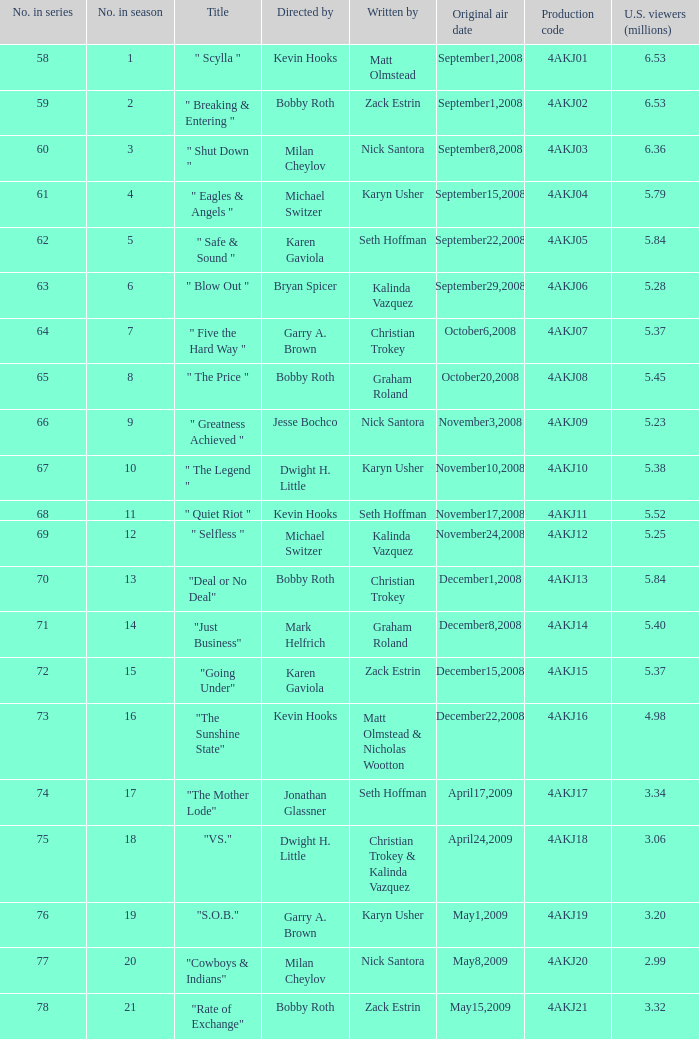Who was the director of the episode with production code 4akj08? Bobby Roth. 